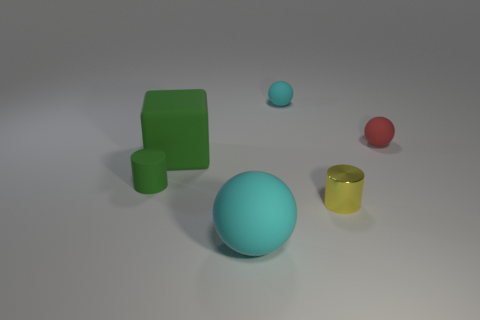Are there any other things that have the same material as the yellow cylinder?
Your answer should be compact. No. There is a cyan object that is in front of the large green matte object; is it the same shape as the red matte object?
Provide a succinct answer. Yes. Is the number of tiny cyan matte objects behind the red rubber thing greater than the number of cubes?
Your answer should be very brief. No. Does the matte thing that is in front of the small yellow shiny thing have the same color as the metal cylinder?
Ensure brevity in your answer.  No. Is there anything else that has the same color as the rubber cube?
Give a very brief answer. Yes. There is a large ball that is to the left of the rubber thing that is right of the tiny ball left of the tiny red matte thing; what color is it?
Your answer should be compact. Cyan. Do the yellow shiny object and the red thing have the same size?
Provide a succinct answer. Yes. What number of other rubber cylinders are the same size as the green matte cylinder?
Provide a succinct answer. 0. There is a tiny thing that is the same color as the cube; what shape is it?
Keep it short and to the point. Cylinder. Is the material of the cylinder that is in front of the small green object the same as the large object that is on the left side of the big cyan rubber thing?
Provide a short and direct response. No. 